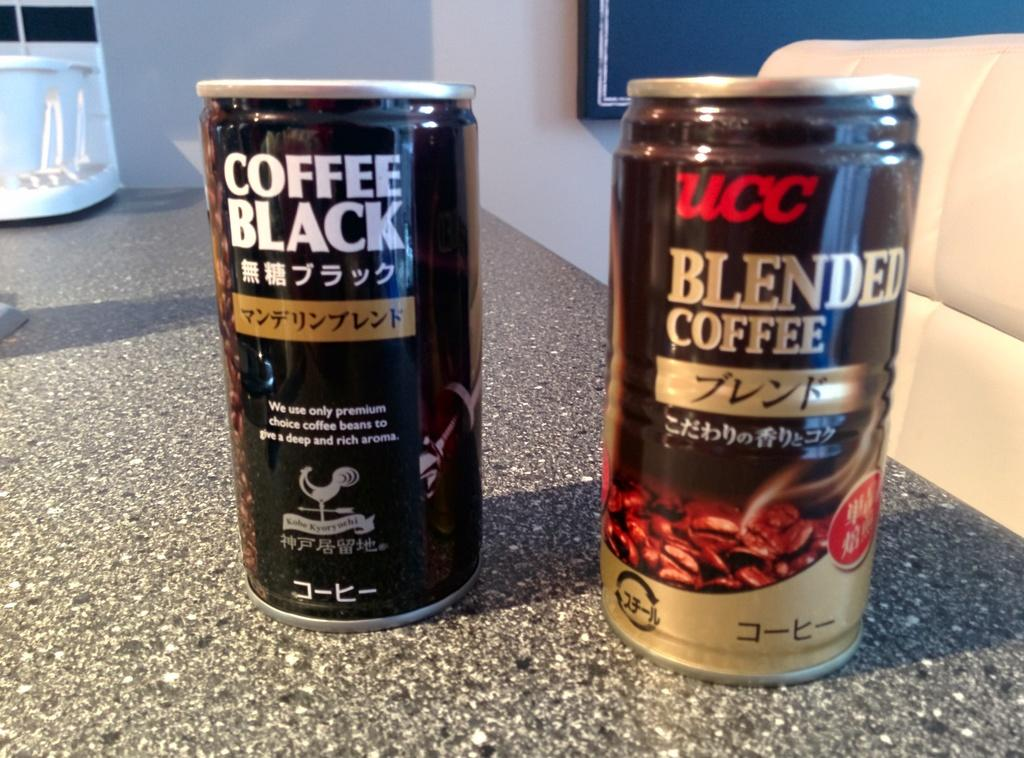<image>
Provide a brief description of the given image. Can of Blended Coffee next to another black can. 